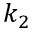<formula> <loc_0><loc_0><loc_500><loc_500>k _ { 2 }</formula> 